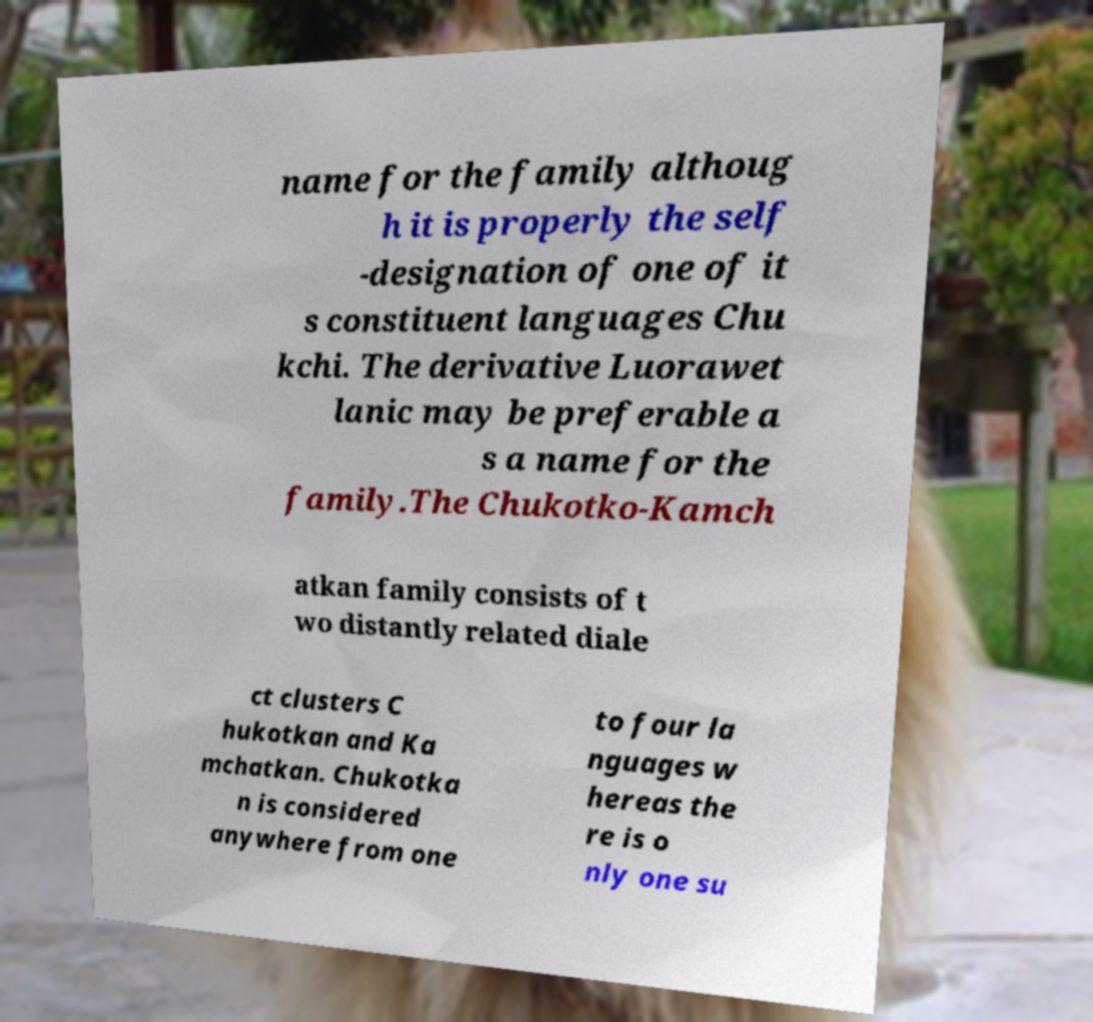Could you assist in decoding the text presented in this image and type it out clearly? name for the family althoug h it is properly the self -designation of one of it s constituent languages Chu kchi. The derivative Luorawet lanic may be preferable a s a name for the family.The Chukotko-Kamch atkan family consists of t wo distantly related diale ct clusters C hukotkan and Ka mchatkan. Chukotka n is considered anywhere from one to four la nguages w hereas the re is o nly one su 